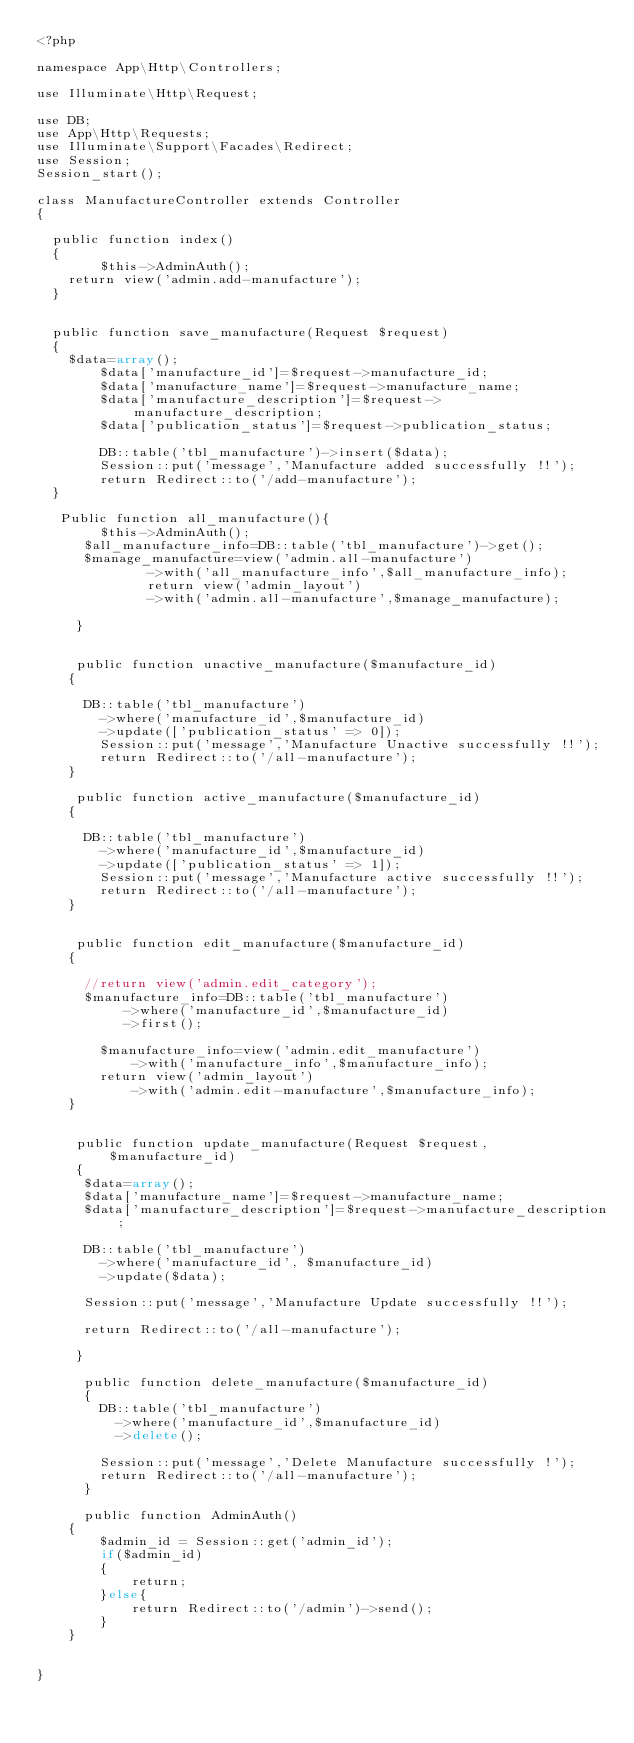Convert code to text. <code><loc_0><loc_0><loc_500><loc_500><_PHP_><?php

namespace App\Http\Controllers;

use Illuminate\Http\Request;

use DB;
use App\Http\Requests;
use Illuminate\Support\Facades\Redirect;
use Session;
Session_start();

class ManufactureController extends Controller
{

	public function index()
	{
        $this->AdminAuth();
		return view('admin.add-manufacture');
	}


	public function save_manufacture(Request $request)
	{
		$data=array();
    		$data['manufacture_id']=$request->manufacture_id;
    		$data['manufacture_name']=$request->manufacture_name;
    		$data['manufacture_description']=$request->manufacture_description;
    		$data['publication_status']=$request->publication_status;

    		DB::table('tbl_manufacture')->insert($data);
    		Session::put('message','Manufacture added successfully !!');
    		return Redirect::to('/add-manufacture');
	}
    
	 Public function all_manufacture(){
        $this->AdminAuth();
    	$all_manufacture_info=DB::table('tbl_manufacture')->get();
    	$manage_manufacture=view('admin.all-manufacture')
    					->with('all_manufacture_info',$all_manufacture_info);
    					return view('admin_layout')
    					->with('admin.all-manufacture',$manage_manufacture);

     }


     public function unactive_manufacture($manufacture_id)
    {
    	
    	DB::table('tbl_manufacture')
    		->where('manufacture_id',$manufacture_id)
    		->update(['publication_status' => 0]);
    		Session::put('message','Manufacture Unactive successfully !!');
    		return Redirect::to('/all-manufacture');
    }

     public function active_manufacture($manufacture_id)
    {
    	
    	DB::table('tbl_manufacture')
    		->where('manufacture_id',$manufacture_id)
    		->update(['publication_status' => 1]);
    		Session::put('message','Manufacture active successfully !!');
    		return Redirect::to('/all-manufacture');
    }


     public function edit_manufacture($manufacture_id)
    {

    	//return view('admin.edit_category');
    	$manufacture_info=DB::table('tbl_manufacture')
    		   ->where('manufacture_id',$manufacture_id)
    		   ->first();

    		$manufacture_info=view('admin.edit_manufacture')
    				->with('manufacture_info',$manufacture_info);
    		return view('admin_layout')
    				->with('admin.edit-manufacture',$manufacture_info);
    }


     public function update_manufacture(Request $request, $manufacture_id)
     {
     	$data=array();
     	$data['manufacture_name']=$request->manufacture_name;
     	$data['manufacture_description']=$request->manufacture_description;

     	DB::table('tbl_manufacture')
     		->where('manufacture_id', $manufacture_id)
     		->update($data);

     	Session::put('message','Manufacture Update successfully !!');

     	return Redirect::to('/all-manufacture');

     }

      public function delete_manufacture($manufacture_id)
      {
      	DB::table('tbl_manufacture')
      		->where('manufacture_id',$manufacture_id)
      		->delete();

      	Session::put('message','Delete Manufacture successfully !');
      	return Redirect::to('/all-manufacture');
      }

      public function AdminAuth()
    {
        $admin_id = Session::get('admin_id');
        if($admin_id)
        {
            return;
        }else{
            return Redirect::to('/admin')->send();
        }
    }


}
</code> 